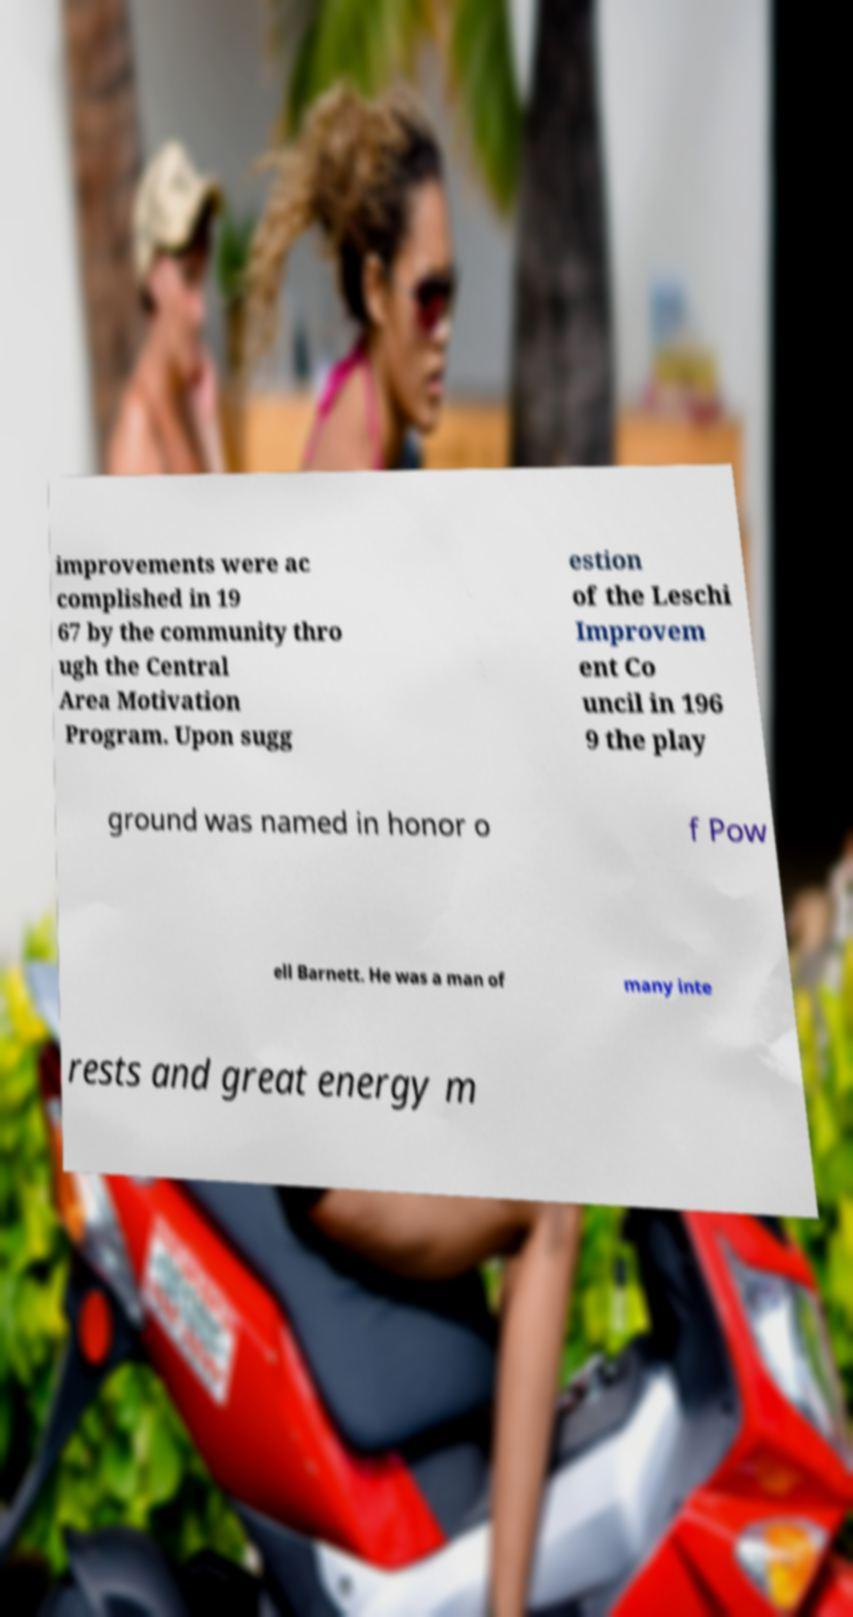Could you extract and type out the text from this image? improvements were ac complished in 19 67 by the community thro ugh the Central Area Motivation Program. Upon sugg estion of the Leschi Improvem ent Co uncil in 196 9 the play ground was named in honor o f Pow ell Barnett. He was a man of many inte rests and great energy m 